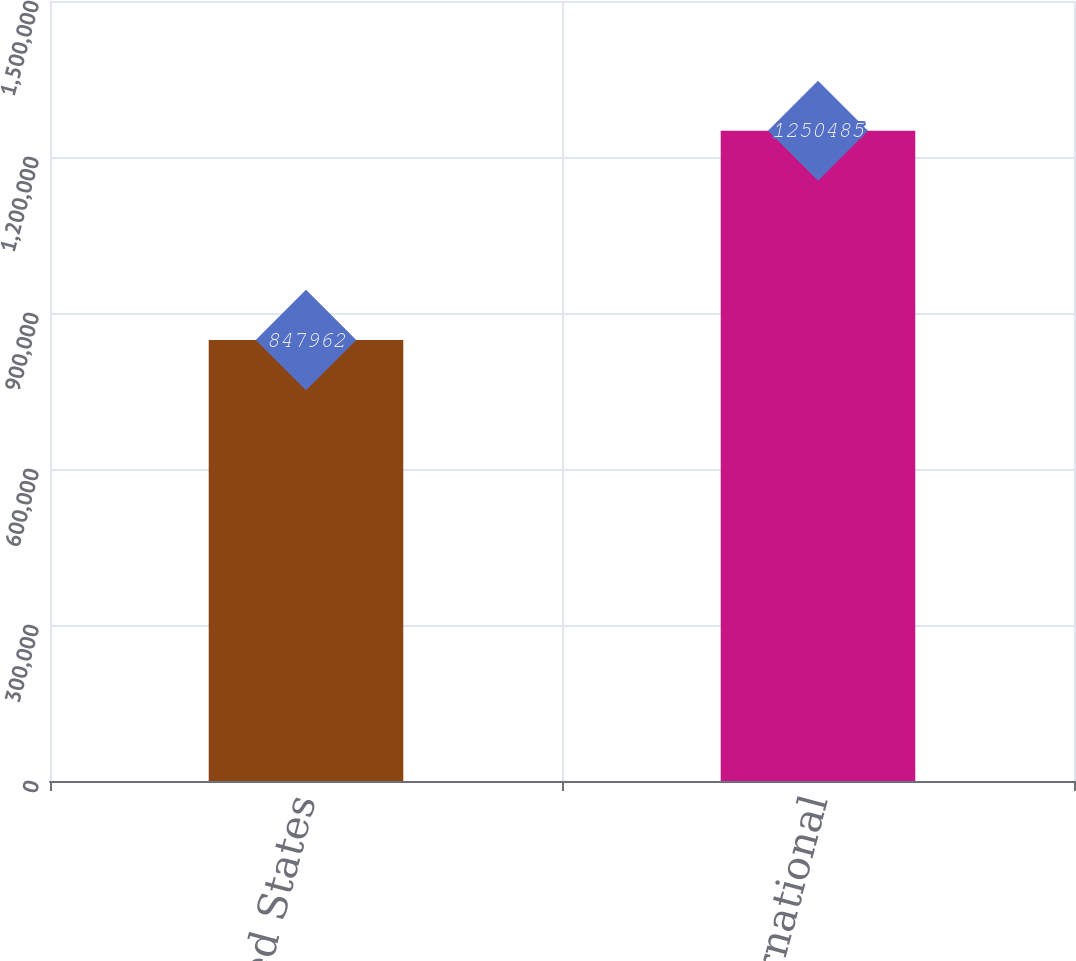Convert chart. <chart><loc_0><loc_0><loc_500><loc_500><bar_chart><fcel>United States<fcel>International<nl><fcel>847962<fcel>1.25048e+06<nl></chart> 